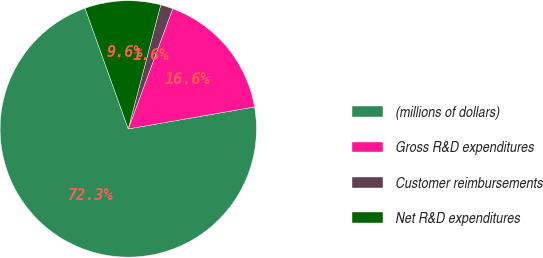Convert chart. <chart><loc_0><loc_0><loc_500><loc_500><pie_chart><fcel>(millions of dollars)<fcel>Gross R&D expenditures<fcel>Customer reimbursements<fcel>Net R&D expenditures<nl><fcel>72.27%<fcel>16.62%<fcel>1.56%<fcel>9.55%<nl></chart> 